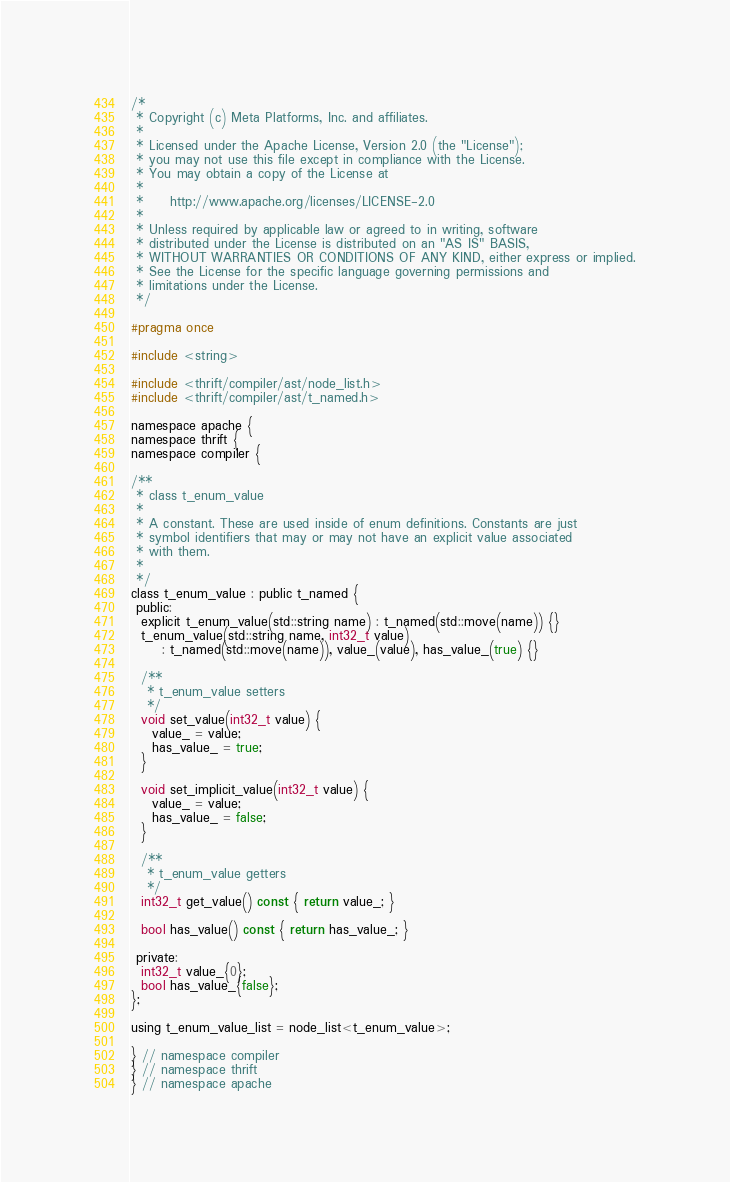<code> <loc_0><loc_0><loc_500><loc_500><_C_>/*
 * Copyright (c) Meta Platforms, Inc. and affiliates.
 *
 * Licensed under the Apache License, Version 2.0 (the "License");
 * you may not use this file except in compliance with the License.
 * You may obtain a copy of the License at
 *
 *     http://www.apache.org/licenses/LICENSE-2.0
 *
 * Unless required by applicable law or agreed to in writing, software
 * distributed under the License is distributed on an "AS IS" BASIS,
 * WITHOUT WARRANTIES OR CONDITIONS OF ANY KIND, either express or implied.
 * See the License for the specific language governing permissions and
 * limitations under the License.
 */

#pragma once

#include <string>

#include <thrift/compiler/ast/node_list.h>
#include <thrift/compiler/ast/t_named.h>

namespace apache {
namespace thrift {
namespace compiler {

/**
 * class t_enum_value
 *
 * A constant. These are used inside of enum definitions. Constants are just
 * symbol identifiers that may or may not have an explicit value associated
 * with them.
 *
 */
class t_enum_value : public t_named {
 public:
  explicit t_enum_value(std::string name) : t_named(std::move(name)) {}
  t_enum_value(std::string name, int32_t value)
      : t_named(std::move(name)), value_(value), has_value_(true) {}

  /**
   * t_enum_value setters
   */
  void set_value(int32_t value) {
    value_ = value;
    has_value_ = true;
  }

  void set_implicit_value(int32_t value) {
    value_ = value;
    has_value_ = false;
  }

  /**
   * t_enum_value getters
   */
  int32_t get_value() const { return value_; }

  bool has_value() const { return has_value_; }

 private:
  int32_t value_{0};
  bool has_value_{false};
};

using t_enum_value_list = node_list<t_enum_value>;

} // namespace compiler
} // namespace thrift
} // namespace apache
</code> 